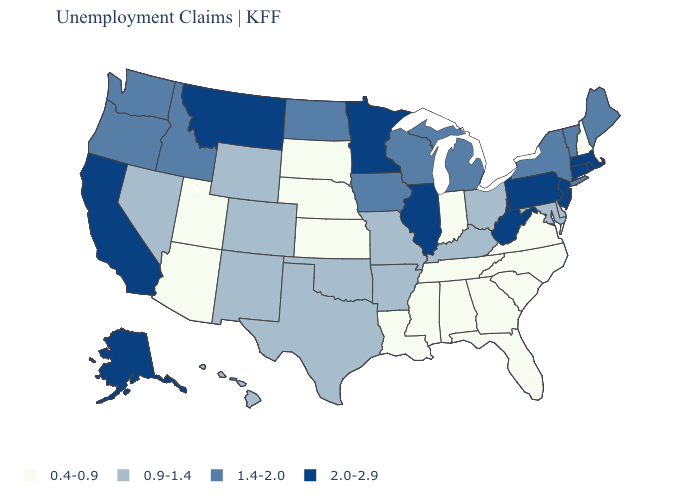Which states have the lowest value in the Northeast?
Keep it brief. New Hampshire. Does the map have missing data?
Give a very brief answer. No. How many symbols are there in the legend?
Keep it brief. 4. What is the value of Delaware?
Concise answer only. 0.9-1.4. Which states have the highest value in the USA?
Give a very brief answer. Alaska, California, Connecticut, Illinois, Massachusetts, Minnesota, Montana, New Jersey, Pennsylvania, Rhode Island, West Virginia. Name the states that have a value in the range 0.4-0.9?
Keep it brief. Alabama, Arizona, Florida, Georgia, Indiana, Kansas, Louisiana, Mississippi, Nebraska, New Hampshire, North Carolina, South Carolina, South Dakota, Tennessee, Utah, Virginia. Does Louisiana have a lower value than Utah?
Be succinct. No. What is the lowest value in states that border New Mexico?
Quick response, please. 0.4-0.9. Is the legend a continuous bar?
Answer briefly. No. Name the states that have a value in the range 0.4-0.9?
Keep it brief. Alabama, Arizona, Florida, Georgia, Indiana, Kansas, Louisiana, Mississippi, Nebraska, New Hampshire, North Carolina, South Carolina, South Dakota, Tennessee, Utah, Virginia. Name the states that have a value in the range 2.0-2.9?
Keep it brief. Alaska, California, Connecticut, Illinois, Massachusetts, Minnesota, Montana, New Jersey, Pennsylvania, Rhode Island, West Virginia. What is the value of North Carolina?
Be succinct. 0.4-0.9. Among the states that border West Virginia , which have the lowest value?
Give a very brief answer. Virginia. Does Pennsylvania have a higher value than Illinois?
Answer briefly. No. What is the highest value in states that border New York?
Concise answer only. 2.0-2.9. 